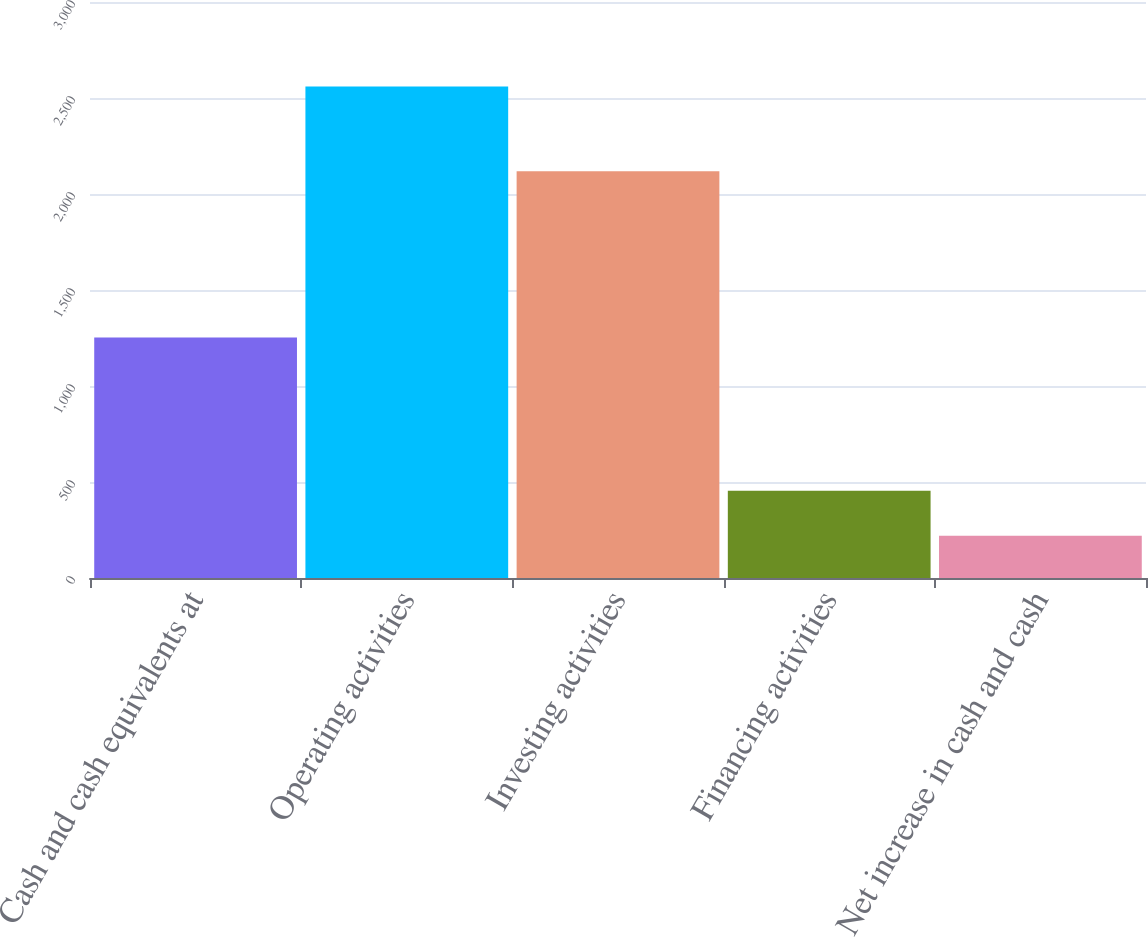Convert chart. <chart><loc_0><loc_0><loc_500><loc_500><bar_chart><fcel>Cash and cash equivalents at<fcel>Operating activities<fcel>Investing activities<fcel>Financing activities<fcel>Net increase in cash and cash<nl><fcel>1253<fcel>2560<fcel>2118<fcel>454<fcel>220<nl></chart> 